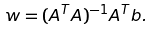<formula> <loc_0><loc_0><loc_500><loc_500>w = ( A ^ { T } A ) ^ { - 1 } A ^ { T } b .</formula> 